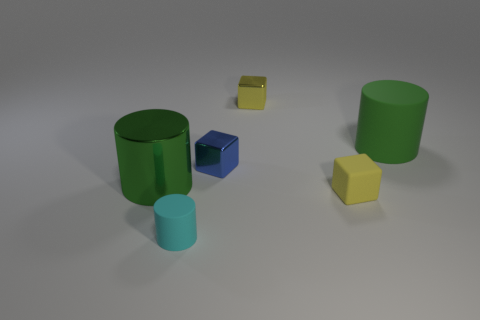Subtract all red cylinders. How many yellow blocks are left? 2 Subtract all tiny yellow cubes. How many cubes are left? 1 Subtract 1 cylinders. How many cylinders are left? 2 Add 4 yellow shiny cylinders. How many objects exist? 10 Subtract all brown cylinders. Subtract all yellow blocks. How many cylinders are left? 3 Subtract all big red spheres. Subtract all tiny cyan matte cylinders. How many objects are left? 5 Add 1 green metal cylinders. How many green metal cylinders are left? 2 Add 4 yellow matte objects. How many yellow matte objects exist? 5 Subtract 1 cyan cylinders. How many objects are left? 5 